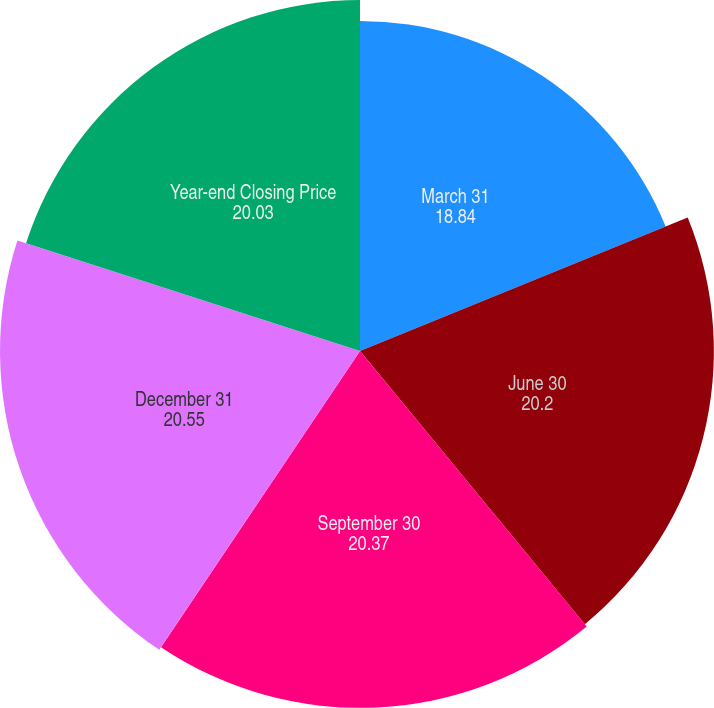Convert chart. <chart><loc_0><loc_0><loc_500><loc_500><pie_chart><fcel>March 31<fcel>June 30<fcel>September 30<fcel>December 31<fcel>Year-end Closing Price<nl><fcel>18.84%<fcel>20.2%<fcel>20.37%<fcel>20.55%<fcel>20.03%<nl></chart> 